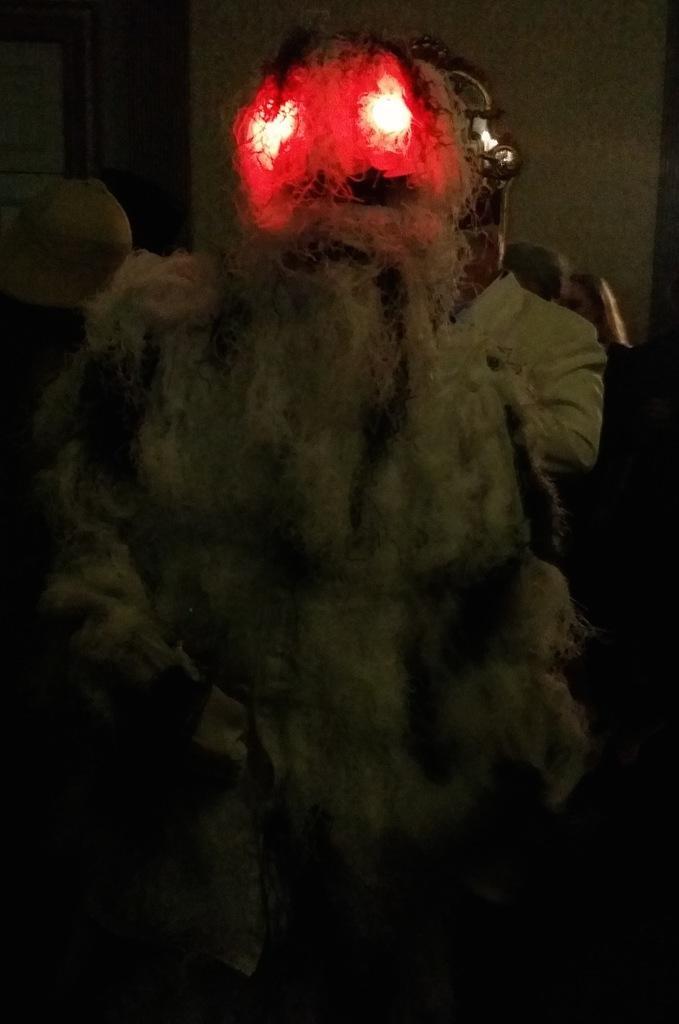Could you give a brief overview of what you see in this image? In this image I can see the group of people and I can see one person wearing the devil costume. 